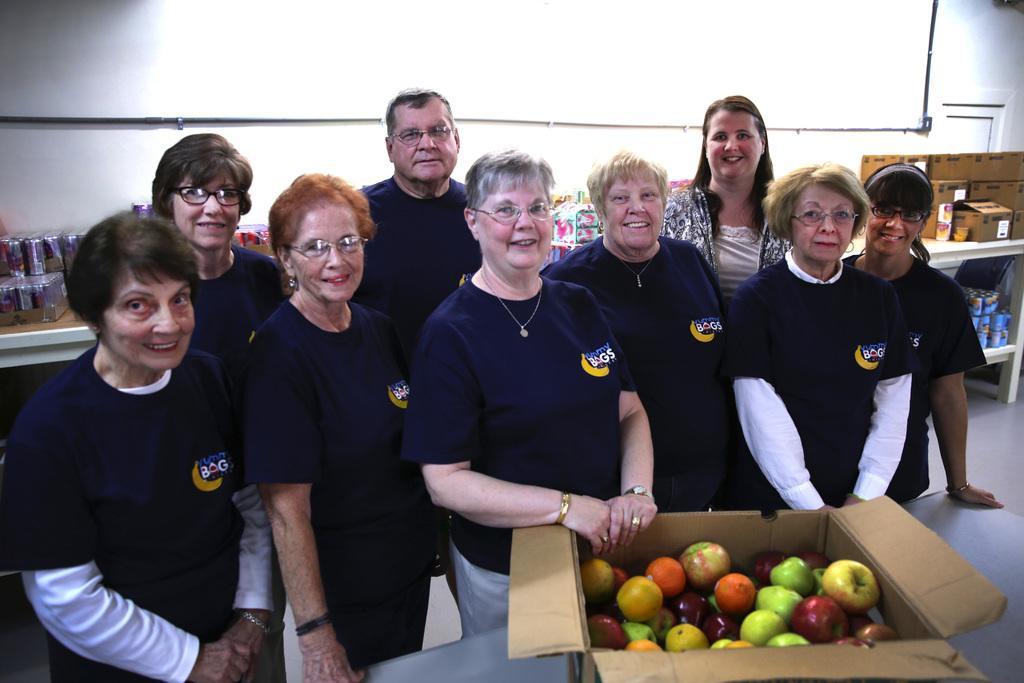Please provide a concise description of this image. In this image we can see few people standing. Some are wearing specs. And there is a box with fruits on a table. In the back there are boxes and some other items on racks. In the background there is a wall with pipes. 